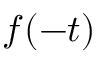<formula> <loc_0><loc_0><loc_500><loc_500>f ( - t )</formula> 